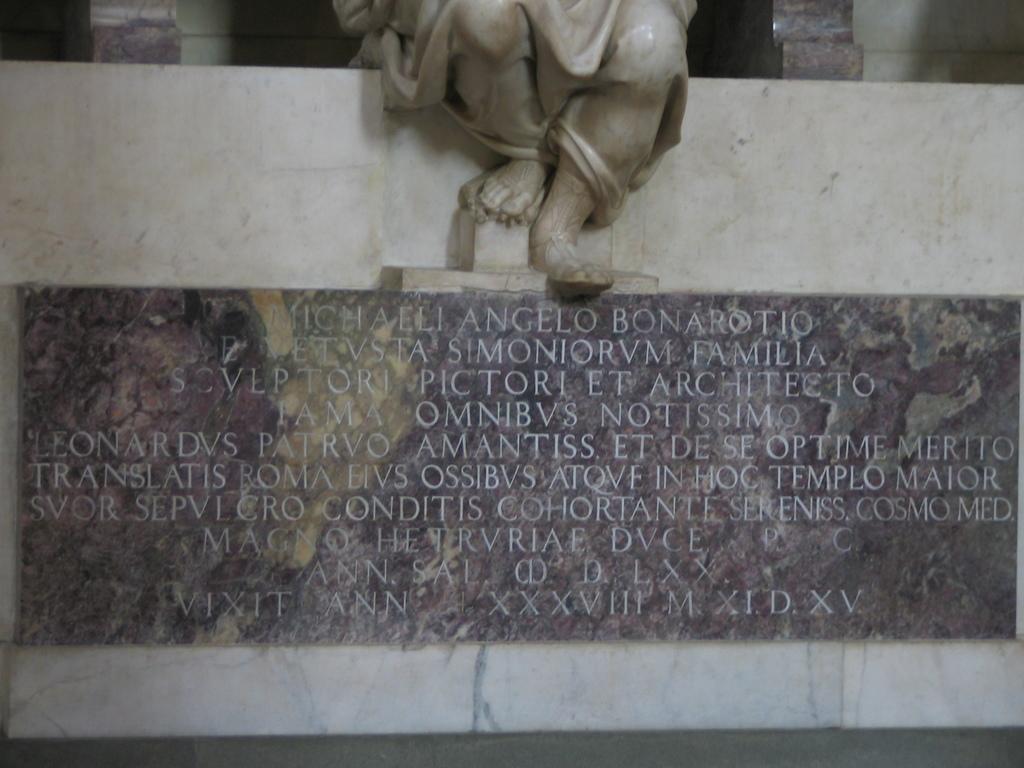Please provide a concise description of this image. This picture shows carved text on the wall and we see a statue 